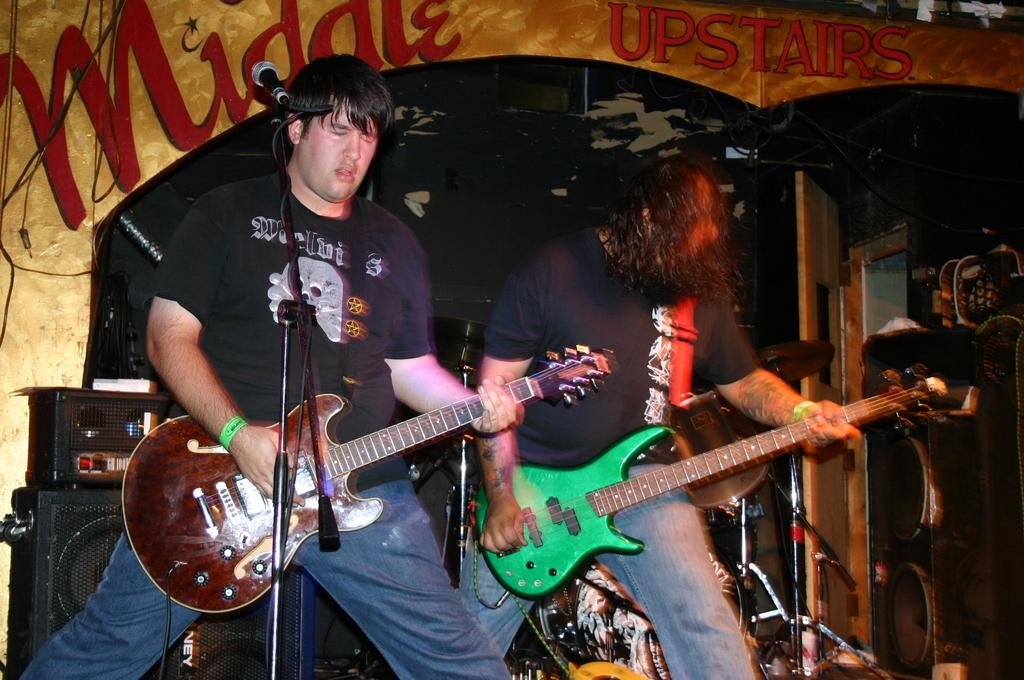How many people are in the image? There are two persons in the center of the image. What are the persons holding? The persons are holding a guitar. What object is in front of the persons? There is a microphone in front of the persons. What can be seen in the background of the image? There are musical instruments visible in the background. What type of laborer can be seen working with the sheep in the image? There are no laborers or sheep present in the image; it features two persons holding a guitar and a microphone in front of them. 